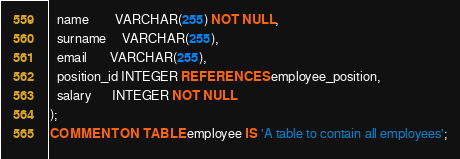<code> <loc_0><loc_0><loc_500><loc_500><_SQL_>  name        VARCHAR(255) NOT NULL,
  surname     VARCHAR(255),
  email       VARCHAR(255),
  position_id INTEGER REFERENCES employee_position,
  salary      INTEGER NOT NULL
);
COMMENT ON TABLE employee IS 'A table to contain all employees';</code> 